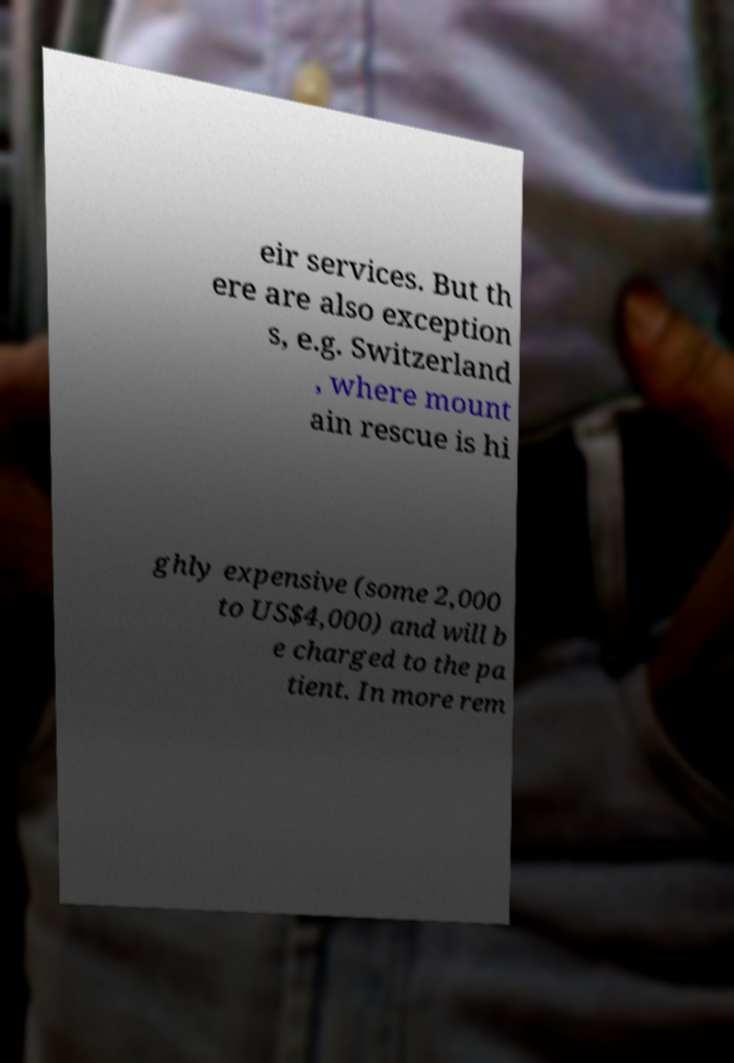Can you read and provide the text displayed in the image?This photo seems to have some interesting text. Can you extract and type it out for me? eir services. But th ere are also exception s, e.g. Switzerland , where mount ain rescue is hi ghly expensive (some 2,000 to US$4,000) and will b e charged to the pa tient. In more rem 